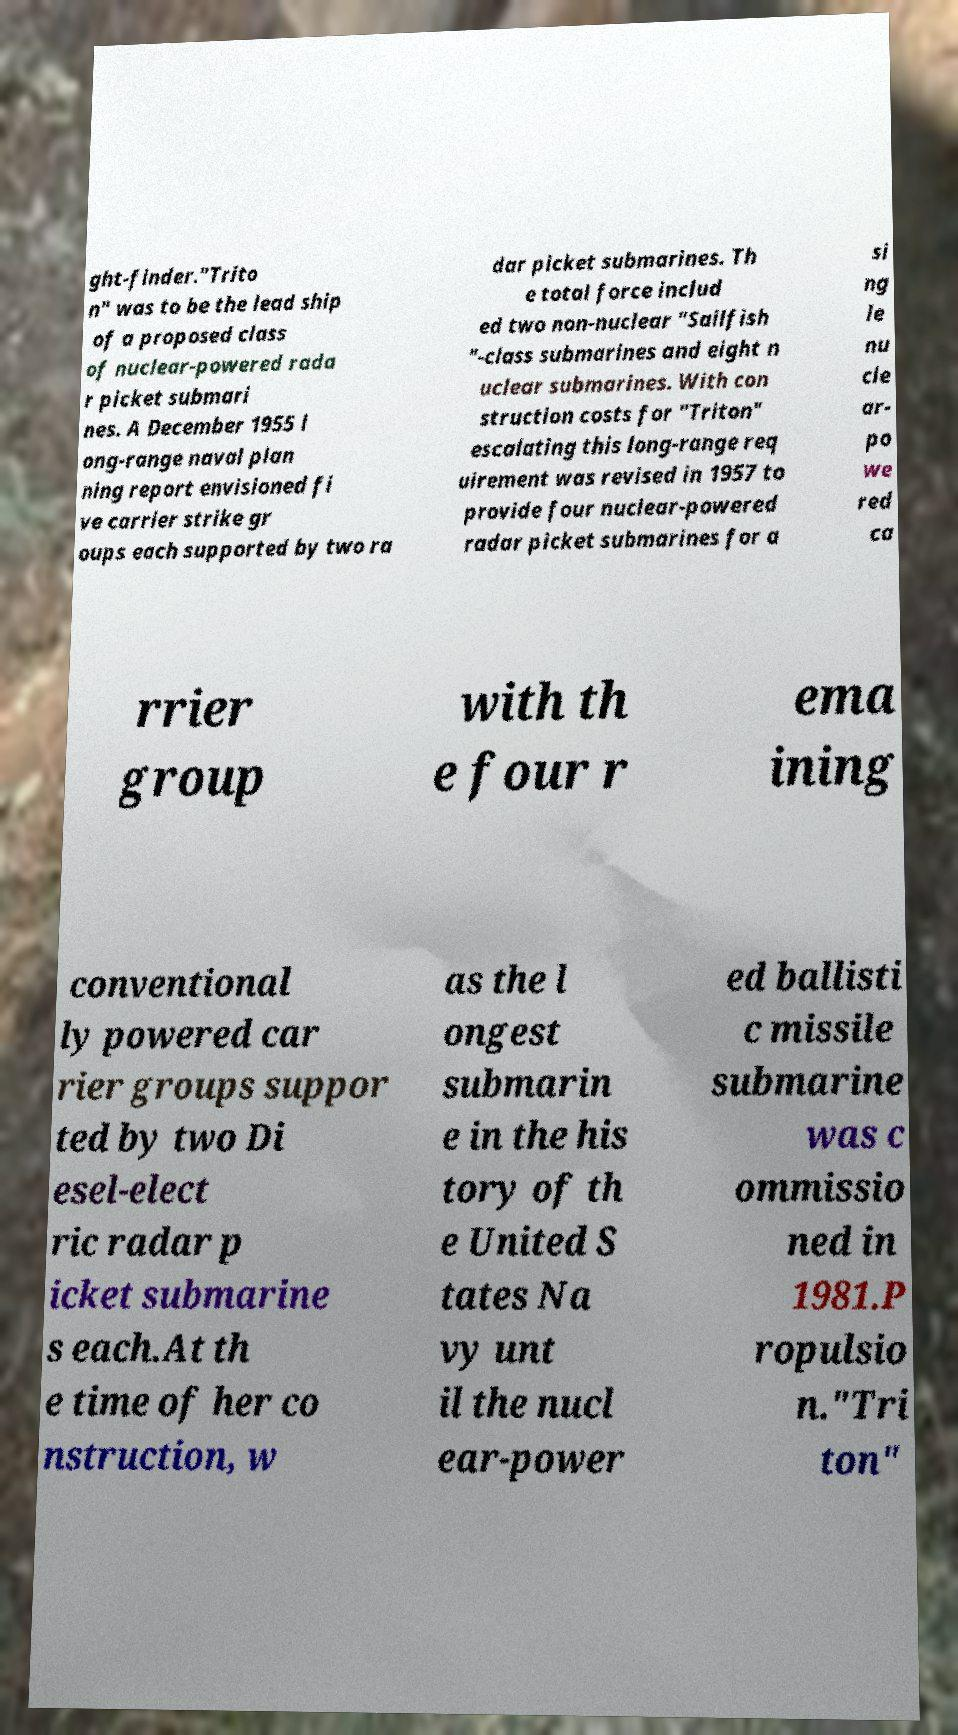Could you extract and type out the text from this image? ght-finder."Trito n" was to be the lead ship of a proposed class of nuclear-powered rada r picket submari nes. A December 1955 l ong-range naval plan ning report envisioned fi ve carrier strike gr oups each supported by two ra dar picket submarines. Th e total force includ ed two non-nuclear "Sailfish "-class submarines and eight n uclear submarines. With con struction costs for "Triton" escalating this long-range req uirement was revised in 1957 to provide four nuclear-powered radar picket submarines for a si ng le nu cle ar- po we red ca rrier group with th e four r ema ining conventional ly powered car rier groups suppor ted by two Di esel-elect ric radar p icket submarine s each.At th e time of her co nstruction, w as the l ongest submarin e in the his tory of th e United S tates Na vy unt il the nucl ear-power ed ballisti c missile submarine was c ommissio ned in 1981.P ropulsio n."Tri ton" 